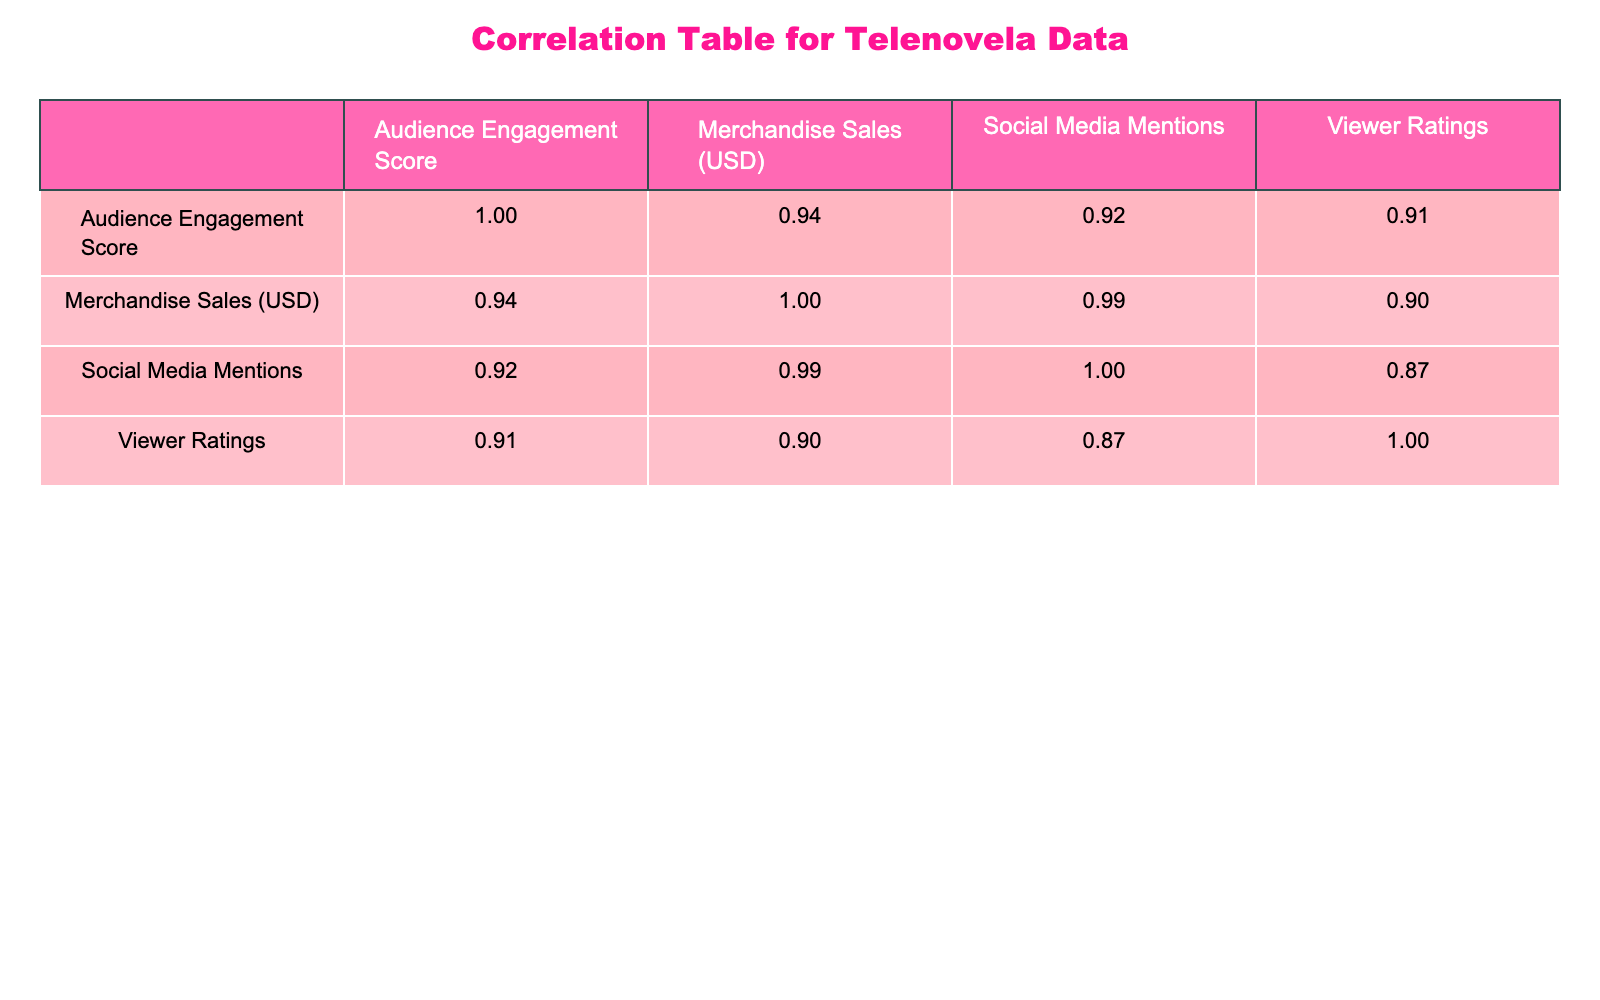What is the audience engagement score for "Un Mundo Nuevo"? The audience engagement score can be found directly in the table under the column labeled "Audience Engagement Score" for the row corresponding to "Un Mundo Nuevo." The value listed is 90.
Answer: 90 What is the merchandise sales amount for "El Privilegio de Amar"? In the table, you can find the merchandise sales for "El Privilegio de Amar" under the "Merchandise Sales (USD)" column. The amount is 100000 USD.
Answer: 100000 Is "Teresa" associated with the highest merchandise sales? By comparing the values in the "Merchandise Sales (USD)" column, "Teresa" has 220000 USD, which is the highest value when compared to the other telenovelas listed in the table.
Answer: Yes What is the difference in audience engagement scores between "Amores Verdaderos" and "El Amor de Mi Vida"? To find the difference, first check the audience engagement scores: "Amores Verdaderos" has a score of 85, and "El Amor de Mi Vida" has a score of 80. The difference is 85 - 80 = 5.
Answer: 5 Which telenovela has the most social media mentions? The most social media mentions can be identified by looking at the "Social Media Mentions" column. "Teresa" has 1800 mentions, which is higher than the others listed.
Answer: Teresa What is the average viewer rating for all telenovelas listed? To find the average viewer rating, add all viewer ratings together: (9.2 + 8.8 + 9.5 + 9.0 + 8.5 + 8.7 + 9.3) = 63.0. There are 7 telenovelas, so divide 63.0 by 7: 63.0 / 7 = 9.0.
Answer: 9.0 Is there a strong correlation between audience engagement score and merchandise sales? The correlation table needs to be examined to determine this relationship. If the correlation coefficient between "Audience Engagement Score" and "Merchandise Sales (USD)" is close to 1 or -1, it indicates a strong correlation. The correlation factor can be interpreted based on statistical standards.
Answer: Yes Which telenovela has the lowest viewer rating? To find this, look at the "Viewer Ratings" column and identify the lowest value. "El Privilegio de Amar" has a viewer rating of 8.5, which is the lowest among the listed telenovelas.
Answer: El Privilegio de Amar 